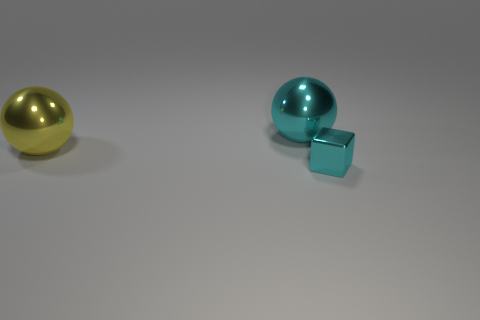The thing that is in front of the big metal thing that is in front of the cyan object behind the small cyan block is made of what material?
Your answer should be very brief. Metal. There is a cyan thing that is on the left side of the metallic block; is it the same shape as the object that is in front of the yellow thing?
Your response must be concise. No. How many other objects are the same material as the cyan block?
Offer a very short reply. 2. The yellow object that is the same material as the small block is what shape?
Give a very brief answer. Sphere. Are there any other things of the same color as the tiny metallic thing?
Provide a short and direct response. Yes. How many small gray matte things are there?
Your response must be concise. 0. What shape is the metal object that is to the left of the tiny cube and right of the big yellow object?
Provide a succinct answer. Sphere. The cyan object that is on the right side of the large thing that is behind the sphere on the left side of the large cyan ball is what shape?
Offer a terse response. Cube. How many cyan cubes have the same size as the cyan ball?
Ensure brevity in your answer.  0. What number of shiny objects are cyan things or tiny gray objects?
Provide a short and direct response. 2. 